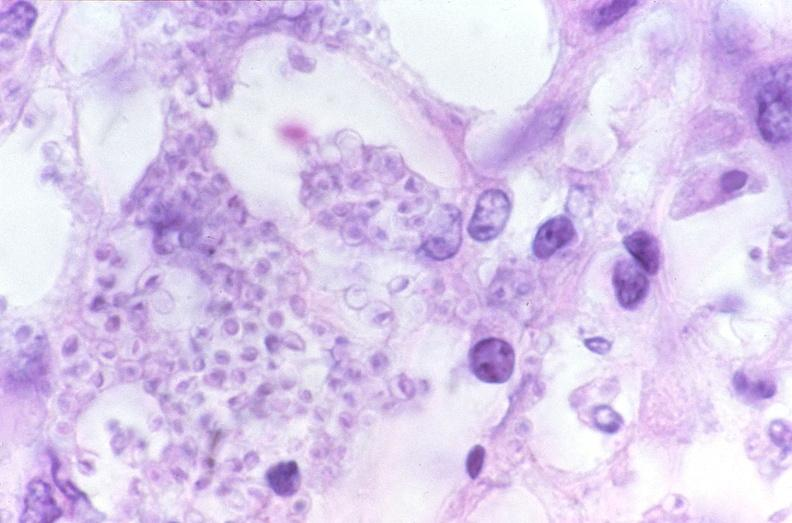what is present?
Answer the question using a single word or phrase. Respiratory 